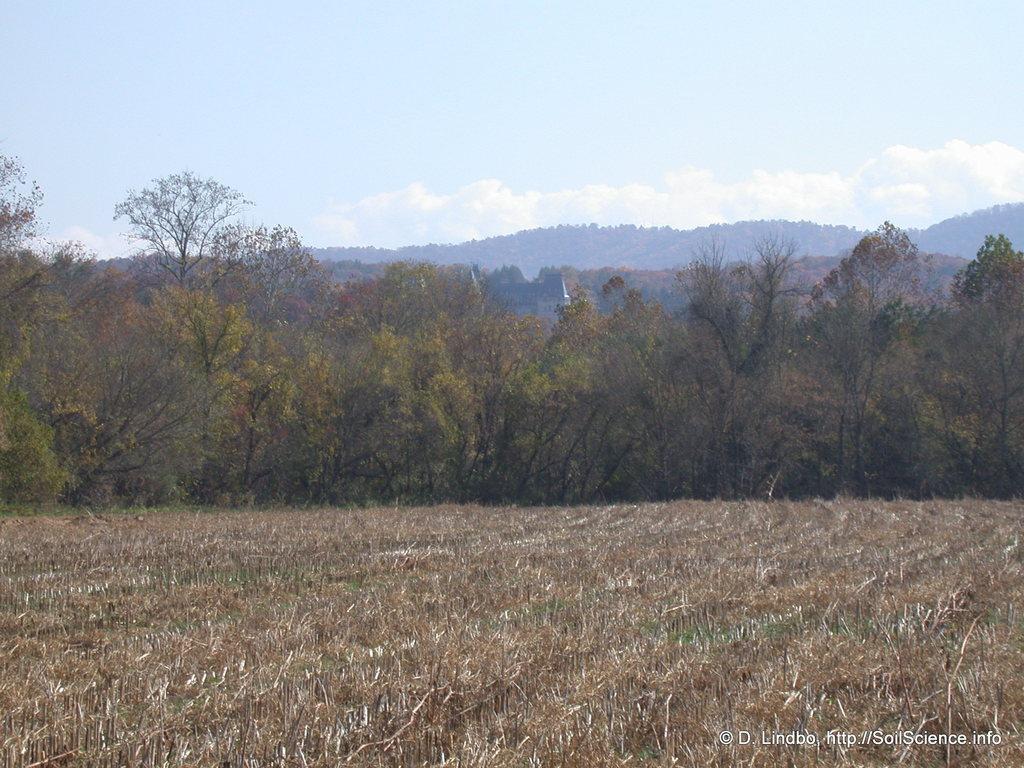Can you describe this image briefly? In this picture we can see trees, mountains and in the background we can see the sky with clouds. 